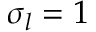<formula> <loc_0><loc_0><loc_500><loc_500>\sigma _ { l } = 1</formula> 